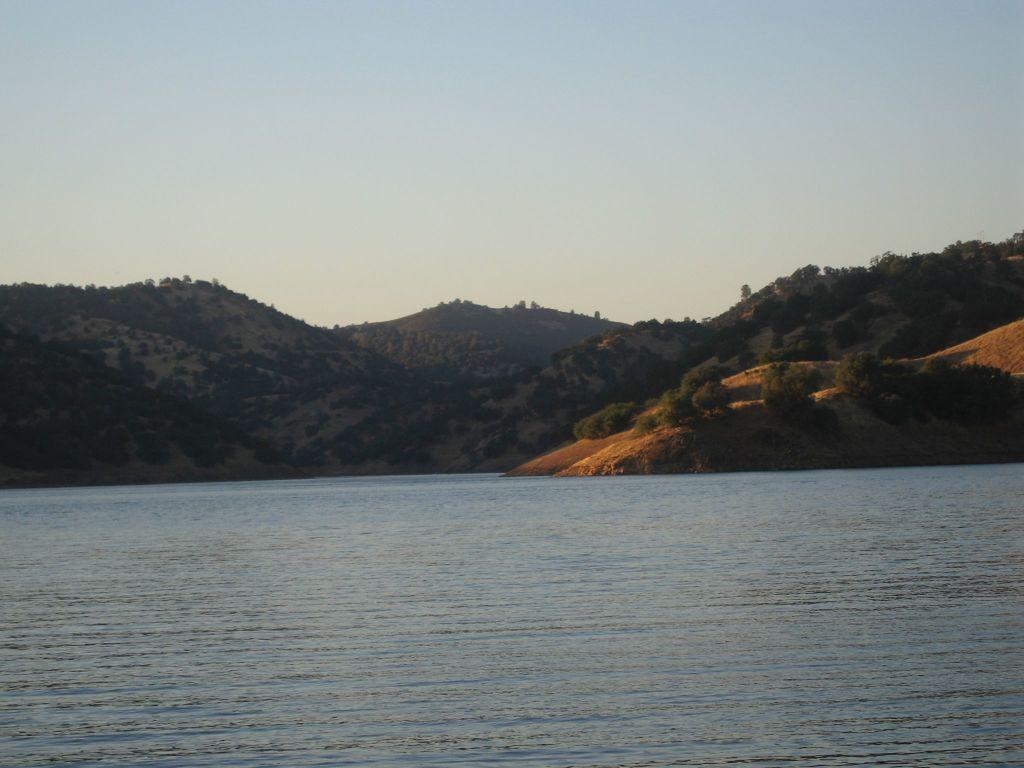What type of landscape is depicted in the image? The image features hills, trees, and plants, suggesting a natural landscape. Can you describe the water in the image? There is water visible in the image. What else can be seen in the sky? The sky is visible in the image. What type of secretary can be seen in the image? There is no secretary present in the image; it features a natural landscape with hills, trees, plants, water, and sky. What is the good-bye message written on the trees in the image? There is no good-bye message written on the trees in the image; it is a natural landscape without any text or human-made elements. 